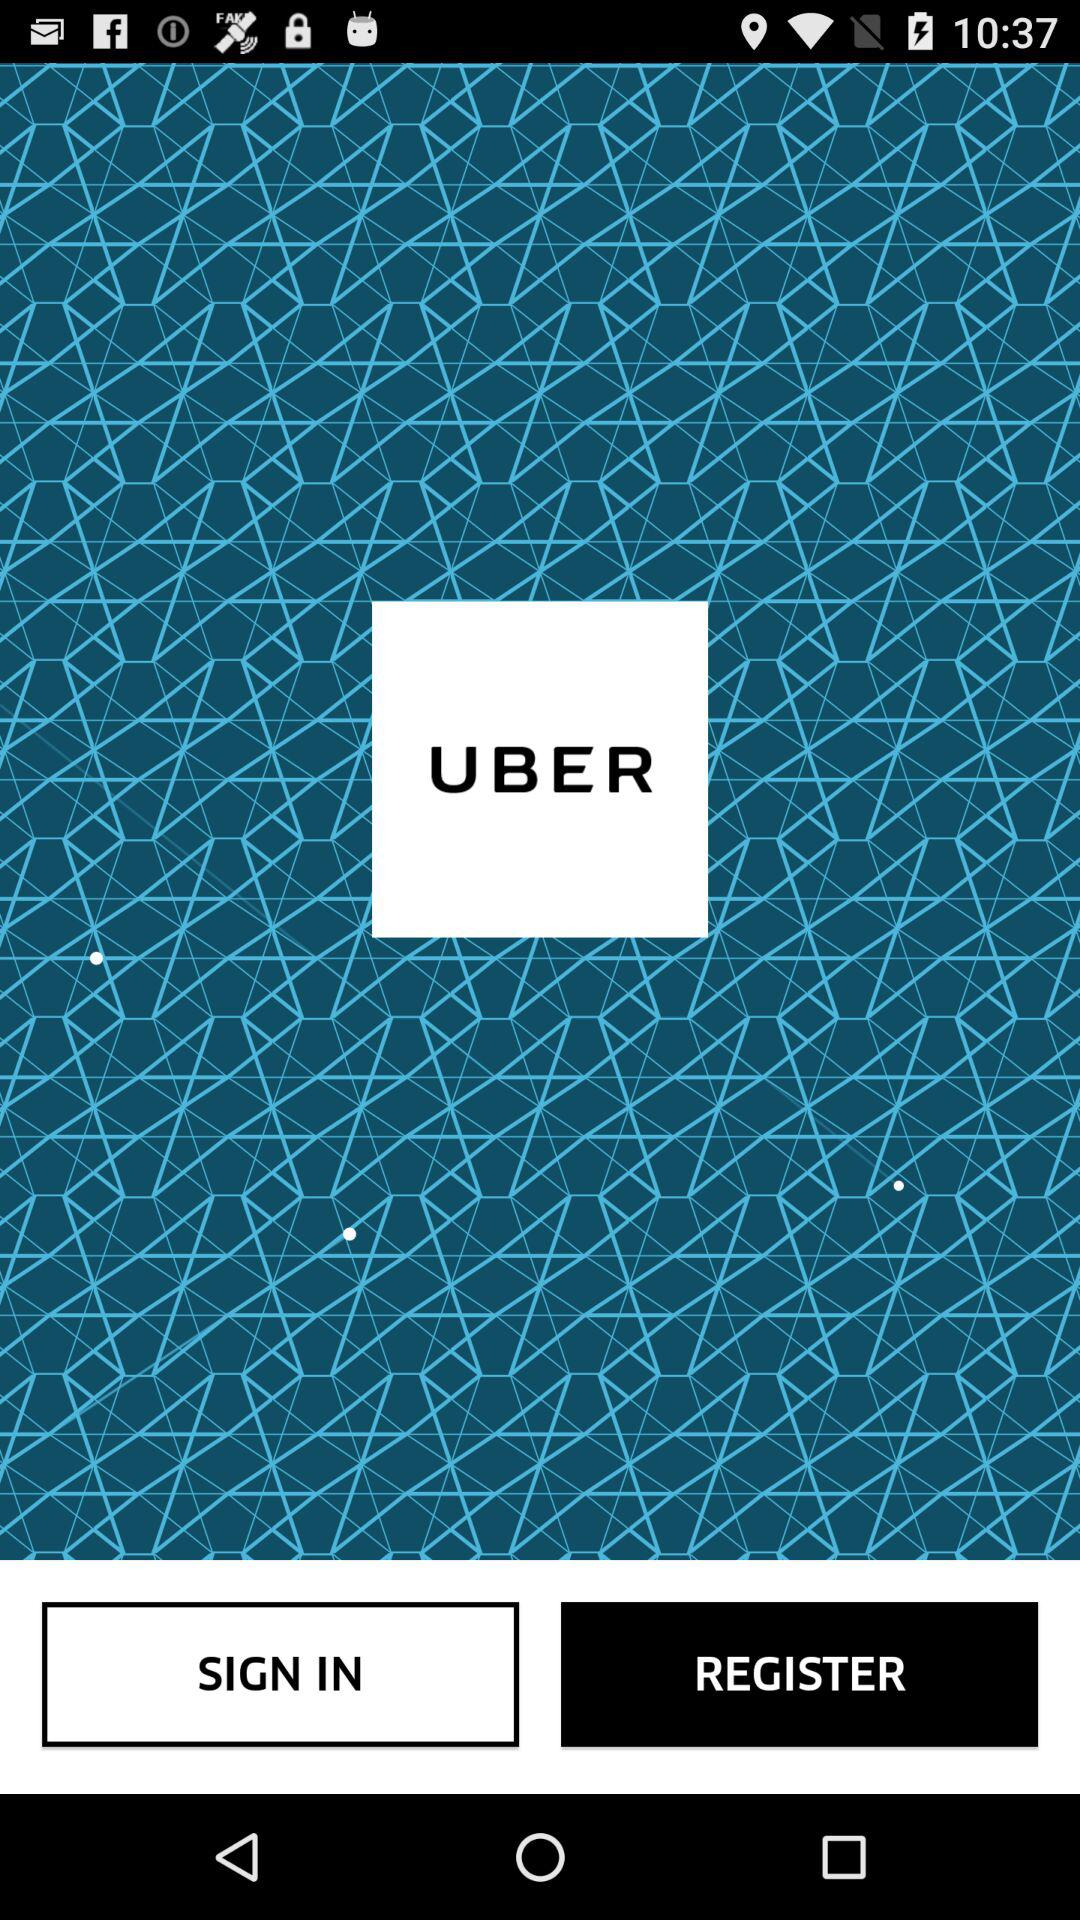What is the app name? The app name is "UBER". 